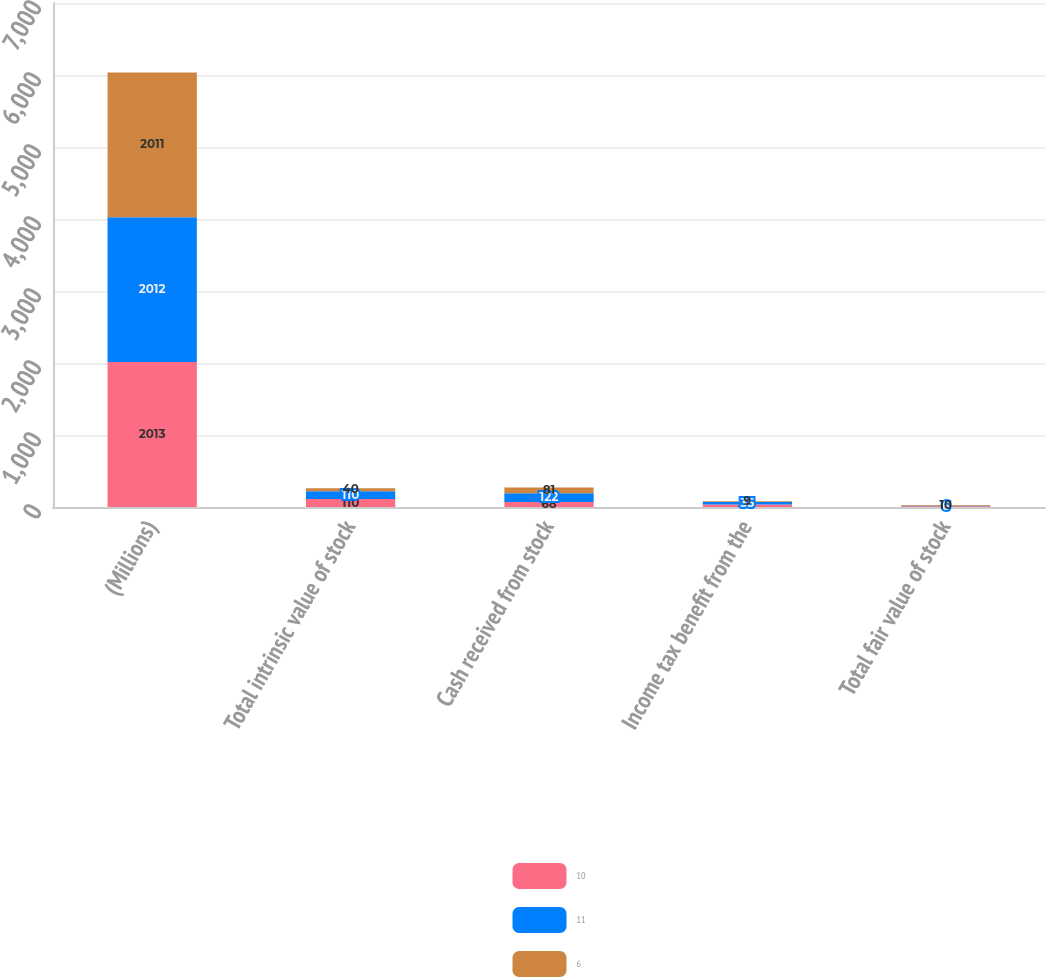Convert chart to OTSL. <chart><loc_0><loc_0><loc_500><loc_500><stacked_bar_chart><ecel><fcel>(Millions)<fcel>Total intrinsic value of stock<fcel>Cash received from stock<fcel>Income tax benefit from the<fcel>Total fair value of stock<nl><fcel>10<fcel>2013<fcel>110<fcel>68<fcel>36<fcel>11<nl><fcel>11<fcel>2012<fcel>110<fcel>122<fcel>35<fcel>6<nl><fcel>6<fcel>2011<fcel>40<fcel>81<fcel>9<fcel>10<nl></chart> 